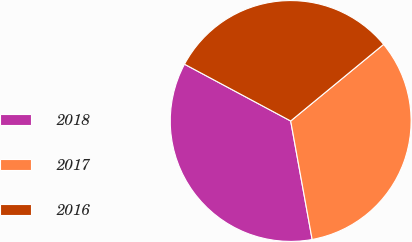Convert chart. <chart><loc_0><loc_0><loc_500><loc_500><pie_chart><fcel>2018<fcel>2017<fcel>2016<nl><fcel>35.67%<fcel>33.12%<fcel>31.21%<nl></chart> 